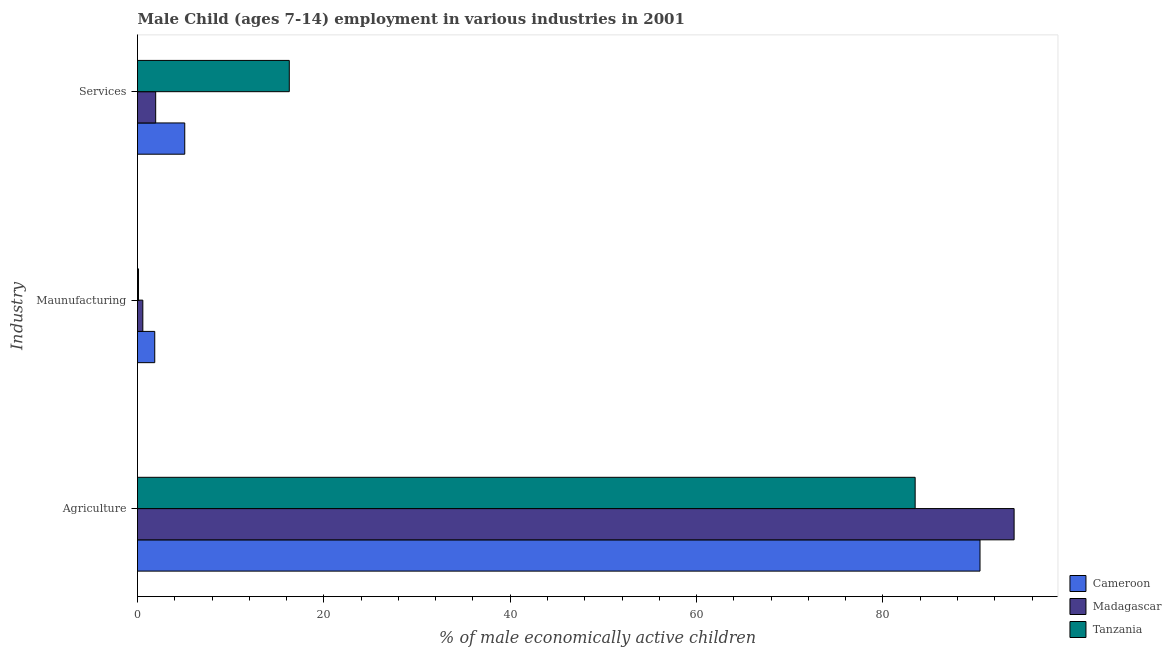How many different coloured bars are there?
Your response must be concise. 3. How many groups of bars are there?
Your answer should be very brief. 3. Are the number of bars on each tick of the Y-axis equal?
Offer a very short reply. Yes. How many bars are there on the 2nd tick from the top?
Your answer should be compact. 3. What is the label of the 3rd group of bars from the top?
Provide a short and direct response. Agriculture. What is the percentage of economically active children in agriculture in Cameroon?
Ensure brevity in your answer.  90.42. Across all countries, what is the maximum percentage of economically active children in agriculture?
Your response must be concise. 94.08. Across all countries, what is the minimum percentage of economically active children in manufacturing?
Offer a very short reply. 0.11. In which country was the percentage of economically active children in agriculture maximum?
Give a very brief answer. Madagascar. In which country was the percentage of economically active children in services minimum?
Provide a short and direct response. Madagascar. What is the total percentage of economically active children in services in the graph?
Make the answer very short. 23.31. What is the difference between the percentage of economically active children in services in Tanzania and that in Cameroon?
Your answer should be very brief. 11.22. What is the difference between the percentage of economically active children in agriculture in Tanzania and the percentage of economically active children in services in Madagascar?
Ensure brevity in your answer.  81.51. What is the average percentage of economically active children in manufacturing per country?
Keep it short and to the point. 0.84. What is the difference between the percentage of economically active children in manufacturing and percentage of economically active children in services in Madagascar?
Your response must be concise. -1.38. In how many countries, is the percentage of economically active children in agriculture greater than 24 %?
Your answer should be very brief. 3. What is the ratio of the percentage of economically active children in services in Madagascar to that in Cameroon?
Make the answer very short. 0.38. Is the percentage of economically active children in agriculture in Cameroon less than that in Madagascar?
Offer a very short reply. Yes. What is the difference between the highest and the second highest percentage of economically active children in agriculture?
Offer a very short reply. 3.66. What is the difference between the highest and the lowest percentage of economically active children in services?
Your answer should be compact. 14.34. In how many countries, is the percentage of economically active children in manufacturing greater than the average percentage of economically active children in manufacturing taken over all countries?
Give a very brief answer. 1. Is the sum of the percentage of economically active children in services in Madagascar and Cameroon greater than the maximum percentage of economically active children in manufacturing across all countries?
Your answer should be very brief. Yes. What does the 3rd bar from the top in Agriculture represents?
Your answer should be compact. Cameroon. What does the 1st bar from the bottom in Services represents?
Provide a short and direct response. Cameroon. Is it the case that in every country, the sum of the percentage of economically active children in agriculture and percentage of economically active children in manufacturing is greater than the percentage of economically active children in services?
Keep it short and to the point. Yes. Are all the bars in the graph horizontal?
Your answer should be very brief. Yes. Does the graph contain grids?
Provide a succinct answer. No. Where does the legend appear in the graph?
Your response must be concise. Bottom right. How many legend labels are there?
Your response must be concise. 3. What is the title of the graph?
Ensure brevity in your answer.  Male Child (ages 7-14) employment in various industries in 2001. Does "China" appear as one of the legend labels in the graph?
Your response must be concise. No. What is the label or title of the X-axis?
Keep it short and to the point. % of male economically active children. What is the label or title of the Y-axis?
Provide a succinct answer. Industry. What is the % of male economically active children of Cameroon in Agriculture?
Ensure brevity in your answer.  90.42. What is the % of male economically active children in Madagascar in Agriculture?
Your answer should be very brief. 94.08. What is the % of male economically active children of Tanzania in Agriculture?
Offer a very short reply. 83.46. What is the % of male economically active children in Cameroon in Maunufacturing?
Provide a short and direct response. 1.85. What is the % of male economically active children in Madagascar in Maunufacturing?
Give a very brief answer. 0.57. What is the % of male economically active children in Tanzania in Maunufacturing?
Make the answer very short. 0.11. What is the % of male economically active children in Cameroon in Services?
Offer a terse response. 5.07. What is the % of male economically active children of Madagascar in Services?
Keep it short and to the point. 1.95. What is the % of male economically active children in Tanzania in Services?
Ensure brevity in your answer.  16.29. Across all Industry, what is the maximum % of male economically active children in Cameroon?
Offer a very short reply. 90.42. Across all Industry, what is the maximum % of male economically active children of Madagascar?
Provide a succinct answer. 94.08. Across all Industry, what is the maximum % of male economically active children of Tanzania?
Keep it short and to the point. 83.46. Across all Industry, what is the minimum % of male economically active children of Cameroon?
Make the answer very short. 1.85. Across all Industry, what is the minimum % of male economically active children in Madagascar?
Offer a terse response. 0.57. Across all Industry, what is the minimum % of male economically active children of Tanzania?
Offer a very short reply. 0.11. What is the total % of male economically active children of Cameroon in the graph?
Provide a succinct answer. 97.34. What is the total % of male economically active children of Madagascar in the graph?
Ensure brevity in your answer.  96.6. What is the total % of male economically active children in Tanzania in the graph?
Ensure brevity in your answer.  99.86. What is the difference between the % of male economically active children of Cameroon in Agriculture and that in Maunufacturing?
Make the answer very short. 88.57. What is the difference between the % of male economically active children of Madagascar in Agriculture and that in Maunufacturing?
Your response must be concise. 93.51. What is the difference between the % of male economically active children of Tanzania in Agriculture and that in Maunufacturing?
Make the answer very short. 83.35. What is the difference between the % of male economically active children in Cameroon in Agriculture and that in Services?
Ensure brevity in your answer.  85.35. What is the difference between the % of male economically active children in Madagascar in Agriculture and that in Services?
Your answer should be compact. 92.13. What is the difference between the % of male economically active children in Tanzania in Agriculture and that in Services?
Make the answer very short. 67.17. What is the difference between the % of male economically active children in Cameroon in Maunufacturing and that in Services?
Provide a short and direct response. -3.22. What is the difference between the % of male economically active children of Madagascar in Maunufacturing and that in Services?
Keep it short and to the point. -1.38. What is the difference between the % of male economically active children of Tanzania in Maunufacturing and that in Services?
Ensure brevity in your answer.  -16.18. What is the difference between the % of male economically active children in Cameroon in Agriculture and the % of male economically active children in Madagascar in Maunufacturing?
Keep it short and to the point. 89.85. What is the difference between the % of male economically active children in Cameroon in Agriculture and the % of male economically active children in Tanzania in Maunufacturing?
Give a very brief answer. 90.31. What is the difference between the % of male economically active children of Madagascar in Agriculture and the % of male economically active children of Tanzania in Maunufacturing?
Your answer should be very brief. 93.97. What is the difference between the % of male economically active children of Cameroon in Agriculture and the % of male economically active children of Madagascar in Services?
Provide a succinct answer. 88.47. What is the difference between the % of male economically active children of Cameroon in Agriculture and the % of male economically active children of Tanzania in Services?
Provide a short and direct response. 74.13. What is the difference between the % of male economically active children of Madagascar in Agriculture and the % of male economically active children of Tanzania in Services?
Ensure brevity in your answer.  77.79. What is the difference between the % of male economically active children in Cameroon in Maunufacturing and the % of male economically active children in Tanzania in Services?
Give a very brief answer. -14.44. What is the difference between the % of male economically active children of Madagascar in Maunufacturing and the % of male economically active children of Tanzania in Services?
Offer a very short reply. -15.72. What is the average % of male economically active children in Cameroon per Industry?
Offer a very short reply. 32.45. What is the average % of male economically active children in Madagascar per Industry?
Give a very brief answer. 32.2. What is the average % of male economically active children of Tanzania per Industry?
Offer a terse response. 33.29. What is the difference between the % of male economically active children of Cameroon and % of male economically active children of Madagascar in Agriculture?
Provide a succinct answer. -3.66. What is the difference between the % of male economically active children of Cameroon and % of male economically active children of Tanzania in Agriculture?
Make the answer very short. 6.96. What is the difference between the % of male economically active children of Madagascar and % of male economically active children of Tanzania in Agriculture?
Ensure brevity in your answer.  10.62. What is the difference between the % of male economically active children in Cameroon and % of male economically active children in Madagascar in Maunufacturing?
Provide a succinct answer. 1.28. What is the difference between the % of male economically active children in Cameroon and % of male economically active children in Tanzania in Maunufacturing?
Keep it short and to the point. 1.74. What is the difference between the % of male economically active children in Madagascar and % of male economically active children in Tanzania in Maunufacturing?
Your response must be concise. 0.46. What is the difference between the % of male economically active children of Cameroon and % of male economically active children of Madagascar in Services?
Your answer should be compact. 3.12. What is the difference between the % of male economically active children in Cameroon and % of male economically active children in Tanzania in Services?
Give a very brief answer. -11.22. What is the difference between the % of male economically active children of Madagascar and % of male economically active children of Tanzania in Services?
Ensure brevity in your answer.  -14.34. What is the ratio of the % of male economically active children in Cameroon in Agriculture to that in Maunufacturing?
Make the answer very short. 48.88. What is the ratio of the % of male economically active children of Madagascar in Agriculture to that in Maunufacturing?
Your answer should be compact. 165.05. What is the ratio of the % of male economically active children in Tanzania in Agriculture to that in Maunufacturing?
Your answer should be compact. 776.98. What is the ratio of the % of male economically active children in Cameroon in Agriculture to that in Services?
Make the answer very short. 17.83. What is the ratio of the % of male economically active children of Madagascar in Agriculture to that in Services?
Keep it short and to the point. 48.25. What is the ratio of the % of male economically active children of Tanzania in Agriculture to that in Services?
Your answer should be compact. 5.12. What is the ratio of the % of male economically active children in Cameroon in Maunufacturing to that in Services?
Ensure brevity in your answer.  0.36. What is the ratio of the % of male economically active children in Madagascar in Maunufacturing to that in Services?
Provide a short and direct response. 0.29. What is the ratio of the % of male economically active children of Tanzania in Maunufacturing to that in Services?
Your answer should be compact. 0.01. What is the difference between the highest and the second highest % of male economically active children of Cameroon?
Offer a terse response. 85.35. What is the difference between the highest and the second highest % of male economically active children of Madagascar?
Keep it short and to the point. 92.13. What is the difference between the highest and the second highest % of male economically active children in Tanzania?
Ensure brevity in your answer.  67.17. What is the difference between the highest and the lowest % of male economically active children of Cameroon?
Provide a succinct answer. 88.57. What is the difference between the highest and the lowest % of male economically active children in Madagascar?
Offer a very short reply. 93.51. What is the difference between the highest and the lowest % of male economically active children in Tanzania?
Make the answer very short. 83.35. 